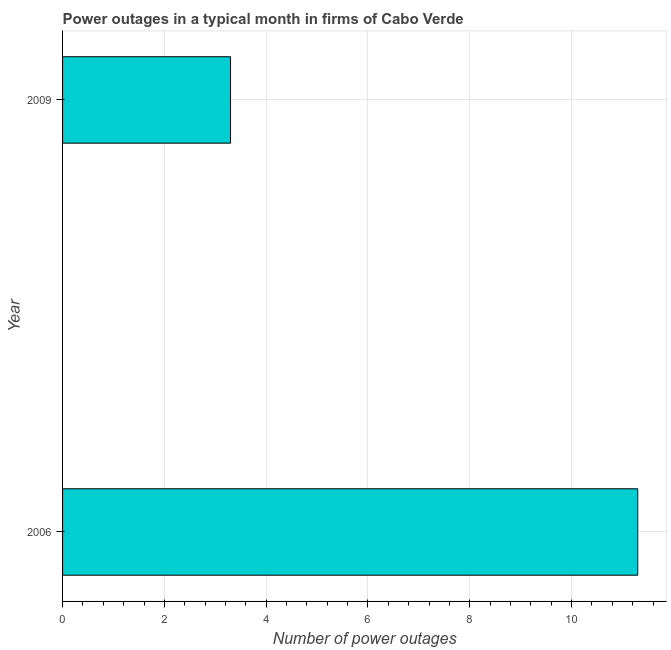What is the title of the graph?
Provide a succinct answer. Power outages in a typical month in firms of Cabo Verde. What is the label or title of the X-axis?
Provide a short and direct response. Number of power outages. What is the label or title of the Y-axis?
Offer a terse response. Year. Across all years, what is the maximum number of power outages?
Keep it short and to the point. 11.3. What is the sum of the number of power outages?
Your answer should be very brief. 14.6. What is the difference between the number of power outages in 2006 and 2009?
Provide a short and direct response. 8. What is the median number of power outages?
Keep it short and to the point. 7.3. In how many years, is the number of power outages greater than 6.8 ?
Provide a short and direct response. 1. What is the ratio of the number of power outages in 2006 to that in 2009?
Keep it short and to the point. 3.42. How many bars are there?
Your response must be concise. 2. Are all the bars in the graph horizontal?
Provide a short and direct response. Yes. How many years are there in the graph?
Give a very brief answer. 2. Are the values on the major ticks of X-axis written in scientific E-notation?
Provide a succinct answer. No. What is the Number of power outages in 2006?
Give a very brief answer. 11.3. What is the difference between the Number of power outages in 2006 and 2009?
Give a very brief answer. 8. What is the ratio of the Number of power outages in 2006 to that in 2009?
Provide a succinct answer. 3.42. 